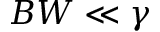Convert formula to latex. <formula><loc_0><loc_0><loc_500><loc_500>B W \ll \gamma</formula> 